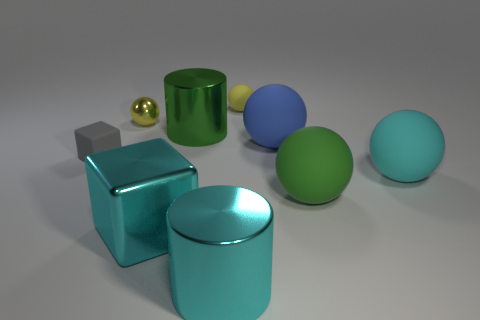What textures are visible on the objects? The textures displayed in the image include a reflective and polished finish on the teal cylinder and the silver cube, a slightly reflective surface on the large cyan ball, and what appears to be a more matte texture on the yellow cylinder and the three other spheres. 